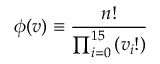Convert formula to latex. <formula><loc_0><loc_0><loc_500><loc_500>\phi ( v ) \equiv \frac { n ! } { \prod _ { i = 0 } ^ { 1 5 } \left ( v _ { i } ! \right ) }</formula> 